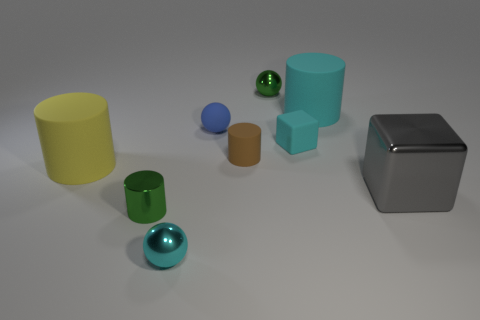Add 1 small red metal balls. How many objects exist? 10 Subtract all cylinders. How many objects are left? 5 Add 5 blocks. How many blocks are left? 7 Add 2 big green metal cylinders. How many big green metal cylinders exist? 2 Subtract 1 green balls. How many objects are left? 8 Subtract all small cyan metallic spheres. Subtract all matte blocks. How many objects are left? 7 